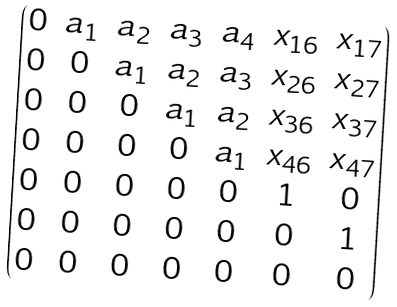<formula> <loc_0><loc_0><loc_500><loc_500>\begin{pmatrix} 0 & a _ { 1 } & a _ { 2 } & a _ { 3 } & a _ { 4 } & x _ { 1 6 } & x _ { 1 7 } \\ 0 & 0 & a _ { 1 } & a _ { 2 } & a _ { 3 } & x _ { 2 6 } & x _ { 2 7 } \\ 0 & 0 & 0 & a _ { 1 } & a _ { 2 } & x _ { 3 6 } & x _ { 3 7 } \\ 0 & 0 & 0 & 0 & a _ { 1 } & x _ { 4 6 } & x _ { 4 7 } \\ 0 & 0 & 0 & 0 & 0 & 1 & 0 \\ 0 & 0 & 0 & 0 & 0 & 0 & 1 \\ 0 & 0 & 0 & 0 & 0 & 0 & 0 \end{pmatrix}</formula> 